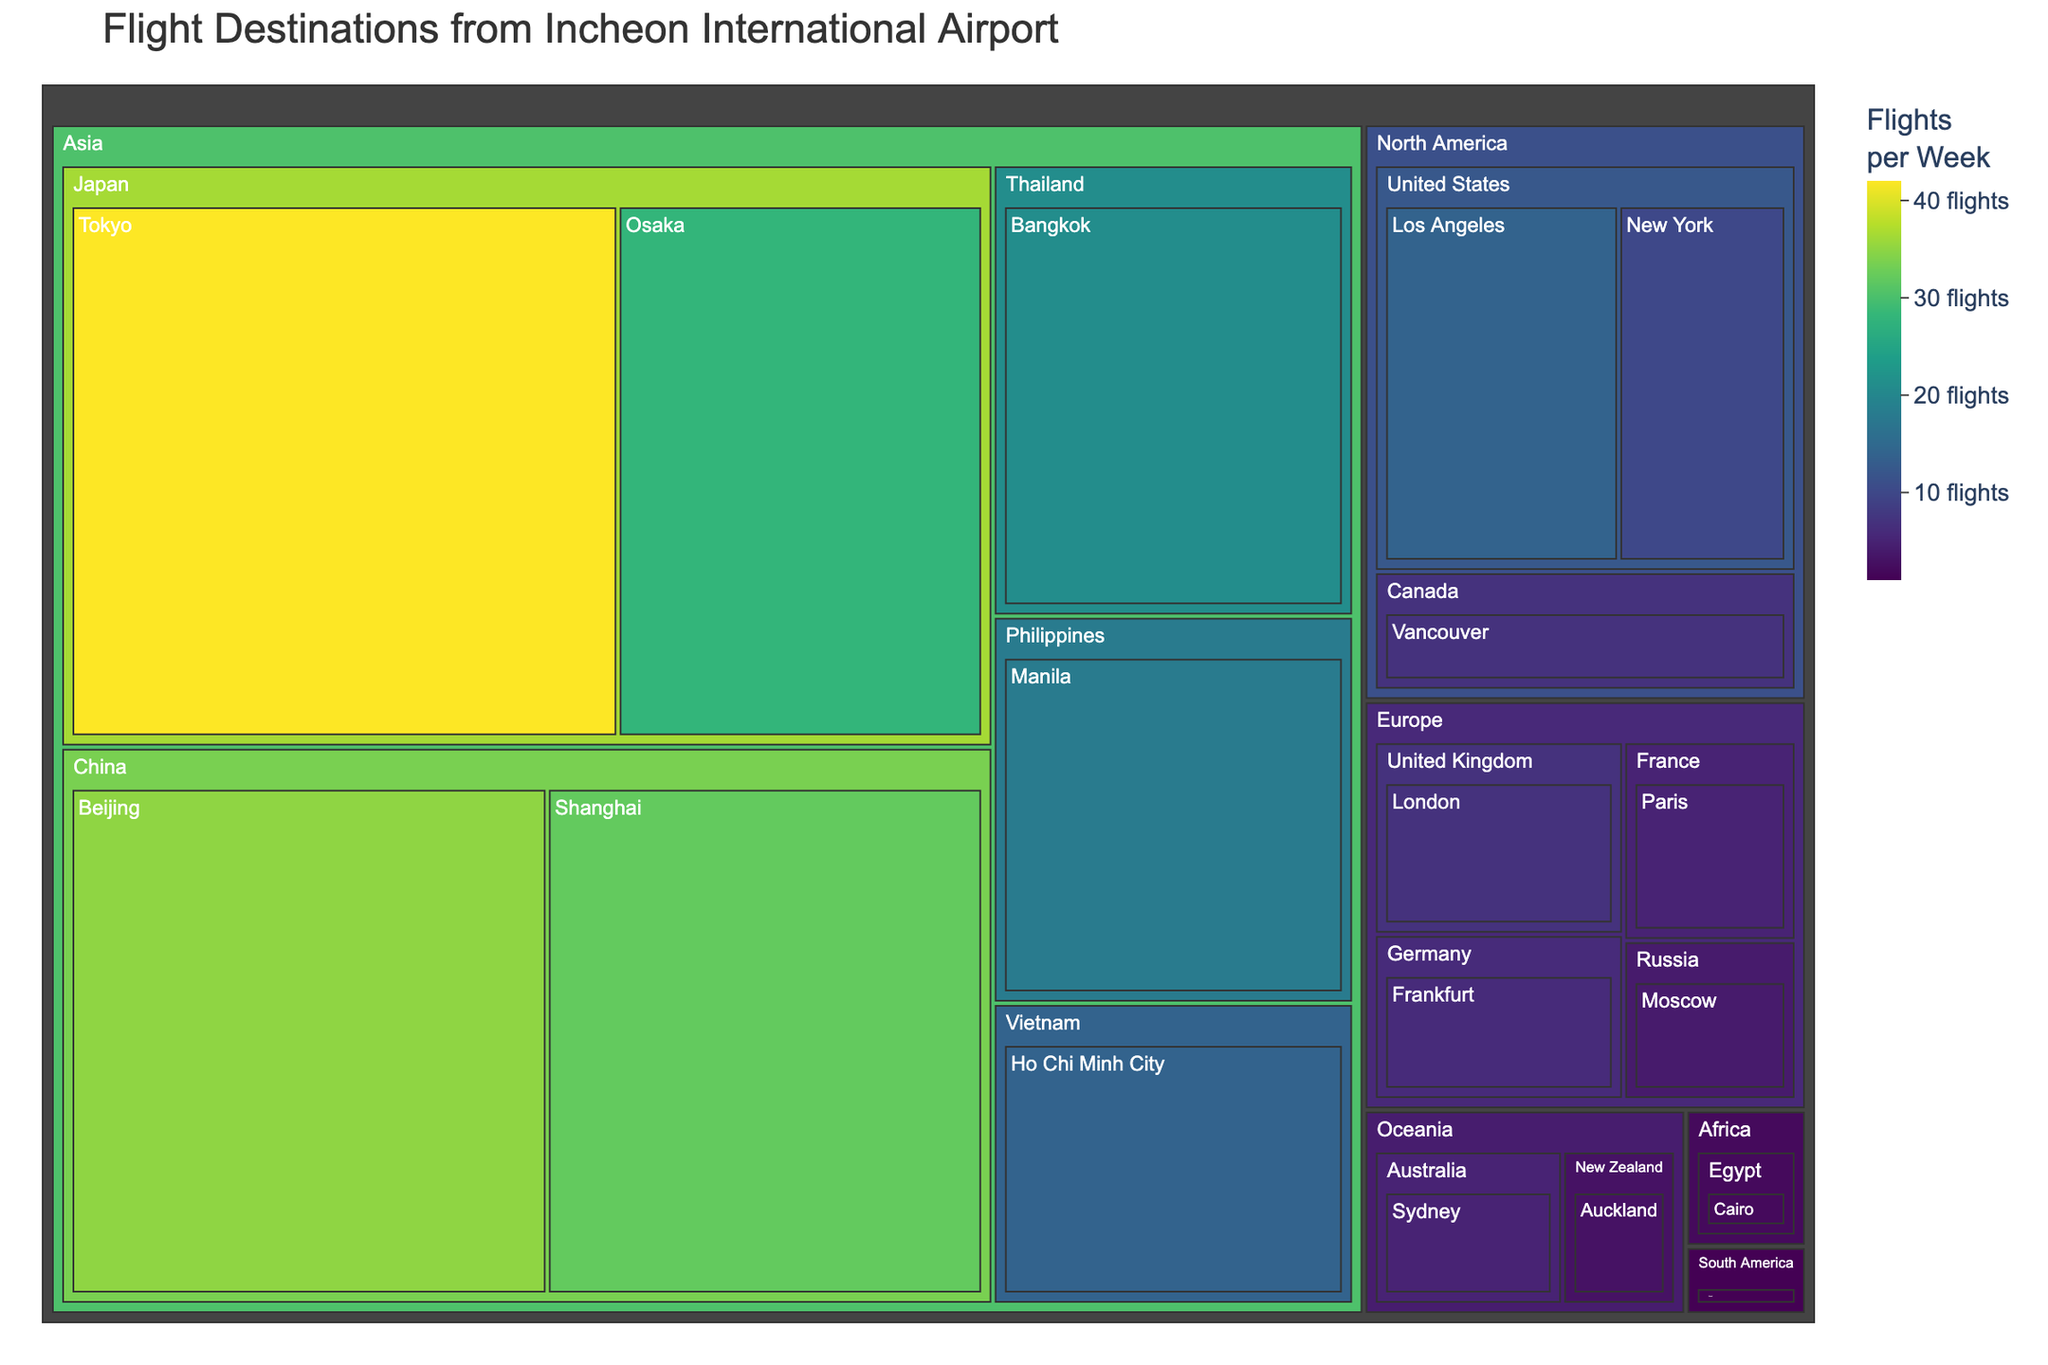What's the title of the figure? The title of a figure is often prominently placed at the top or in a central position. In this treemap's case, the title should concisely describe the visualized data.
Answer: Flight Destinations from Incheon International Airport Which country in Asia has the highest number of flights per week? In the treemap, locate the continent "Asia" and observe the size and color intensity of the countries within it. The country with the largest and most intense segment should have the highest number of flights per week.
Answer: Japan How many flights per week fly to European destinations? Sum the individual flights per week for each European city listed in the treemap (London, Paris, Frankfurt, and Moscow). Calculate 7 (London) + 5 (Paris) + 6 (Frankfurt) + 4 (Moscow).
Answer: 22 Which destination in Oceania has fewer flights per week, Auckland or Sydney? Oceania contains both Auckland and Sydney in the treemap. Compare the sizes of their respective segments; the smaller segment corresponds to fewer flights per week.
Answer: Auckland Out of North American destinations, which city has the most flights per week? In the treemap, find the segment labeled "North America." Within this segment, identify and compare the sizes and colors of Los Angeles, New York, and Vancouver segments. The largest and most intense one is the answer.
Answer: Los Angeles What's the total number of flights per week to destinations in China? Find all destinations listed under China within "Asia" and add the number of flights per week for each (Beijing, 35; Shanghai, 32).
Answer: 67 Between Africa and South America, which continent has more flights per week? Compare the segments for Africa and South America in the treemap. Calculate the total for each: Africa (Cairo, 2) and South America (Sao Paulo, 1).
Answer: Africa How many destinations are served in the Asian continent? Identify all the distinct segments under the "Asia" category in the treemap. Count each unique destination (Tokyo, Osaka, Beijing, Shanghai, Bangkok, Ho Chi Minh City, Manila).
Answer: 7 Which of Japan's destinations have more flights per week, Tokyo or Osaka? Find "Japan" under "Asia" and compare the segments for Tokyo and Osaka. The larger segment in terms of size and more intense color will have more flights.
Answer: Tokyo 